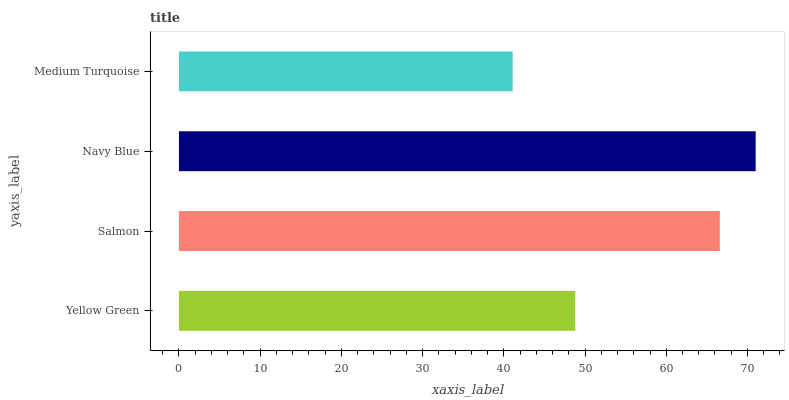Is Medium Turquoise the minimum?
Answer yes or no. Yes. Is Navy Blue the maximum?
Answer yes or no. Yes. Is Salmon the minimum?
Answer yes or no. No. Is Salmon the maximum?
Answer yes or no. No. Is Salmon greater than Yellow Green?
Answer yes or no. Yes. Is Yellow Green less than Salmon?
Answer yes or no. Yes. Is Yellow Green greater than Salmon?
Answer yes or no. No. Is Salmon less than Yellow Green?
Answer yes or no. No. Is Salmon the high median?
Answer yes or no. Yes. Is Yellow Green the low median?
Answer yes or no. Yes. Is Medium Turquoise the high median?
Answer yes or no. No. Is Medium Turquoise the low median?
Answer yes or no. No. 